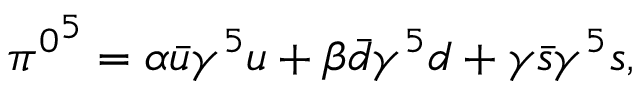<formula> <loc_0><loc_0><loc_500><loc_500>\begin{array} { r } { { \pi ^ { 0 } } ^ { 5 } = \alpha \bar { u } \gamma ^ { 5 } u + \beta \bar { d } \gamma ^ { 5 } d + \gamma \bar { s } \gamma ^ { 5 } s , } \end{array}</formula> 